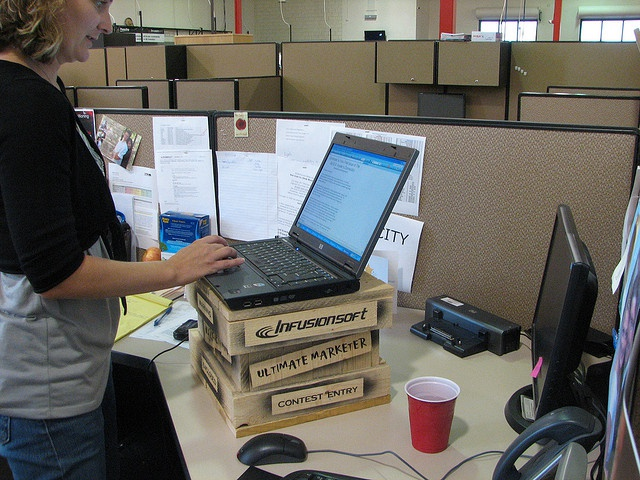Describe the objects in this image and their specific colors. I can see people in darkgray, black, gray, and maroon tones, laptop in black, gray, and lightblue tones, tv in black and gray tones, cup in black, brown, maroon, darkgray, and lavender tones, and keyboard in black and purple tones in this image. 